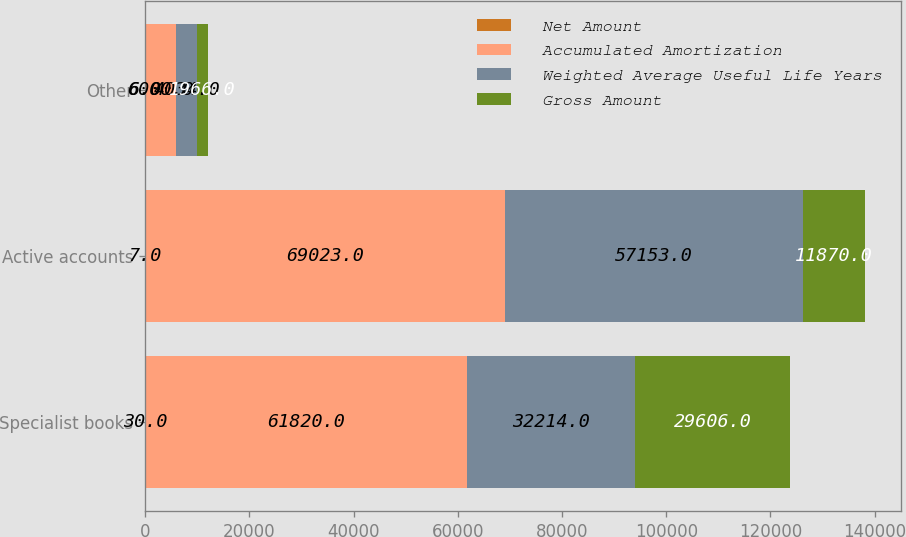<chart> <loc_0><loc_0><loc_500><loc_500><stacked_bar_chart><ecel><fcel>Specialist books<fcel>Active accounts<fcel>Other<nl><fcel>Net Amount<fcel>30<fcel>7<fcel>6<nl><fcel>Accumulated Amortization<fcel>61820<fcel>69023<fcel>6000<nl><fcel>Weighted Average Useful Life Years<fcel>32214<fcel>57153<fcel>4034<nl><fcel>Gross Amount<fcel>29606<fcel>11870<fcel>1966<nl></chart> 